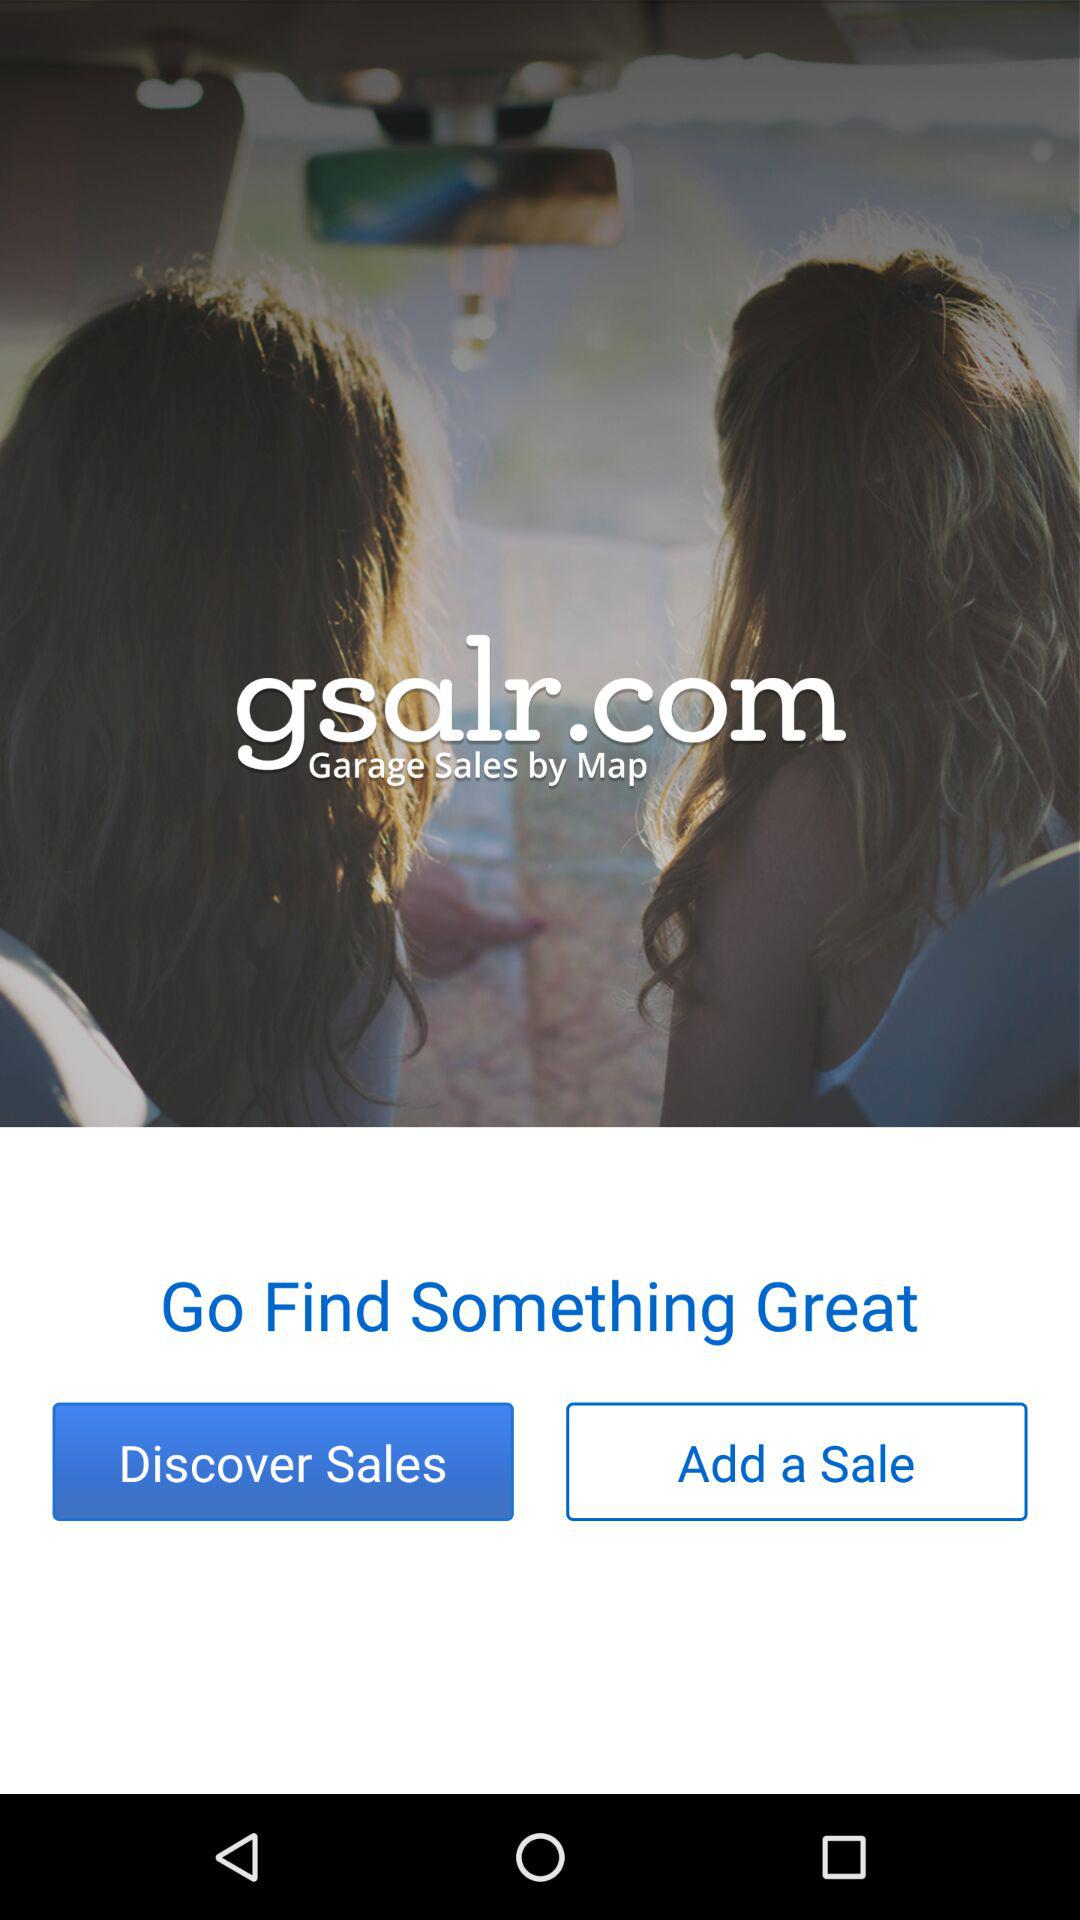What is the application name? The application name is "Garage Sale Map - gsalr.com". 